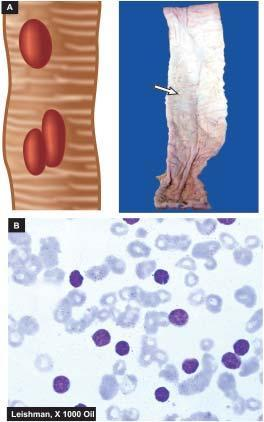 , typhoid ulcers in the small intestine appear characteristically oval with whose long axis parallel to the long axis of the bowel?
Answer the question using a single word or phrase. Their 